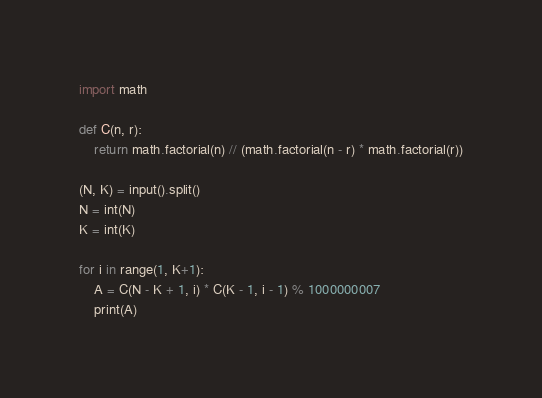Convert code to text. <code><loc_0><loc_0><loc_500><loc_500><_Python_>import math

def C(n, r):
    return math.factorial(n) // (math.factorial(n - r) * math.factorial(r))

(N, K) = input().split()
N = int(N)
K = int(K)

for i in range(1, K+1):
    A = C(N - K + 1, i) * C(K - 1, i - 1) % 1000000007
    print(A)
</code> 